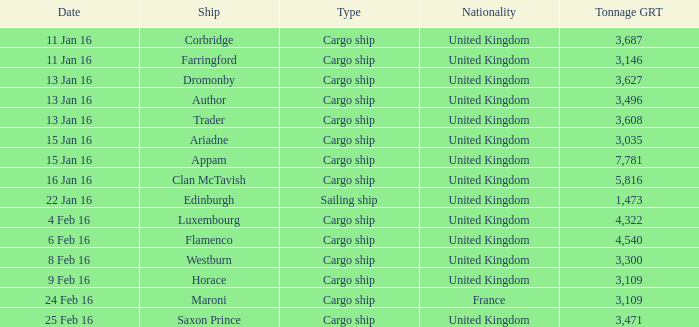On february 4, 2016, what was the cumulative grt of the cargo ships that were either captured or submerged? 1.0. 